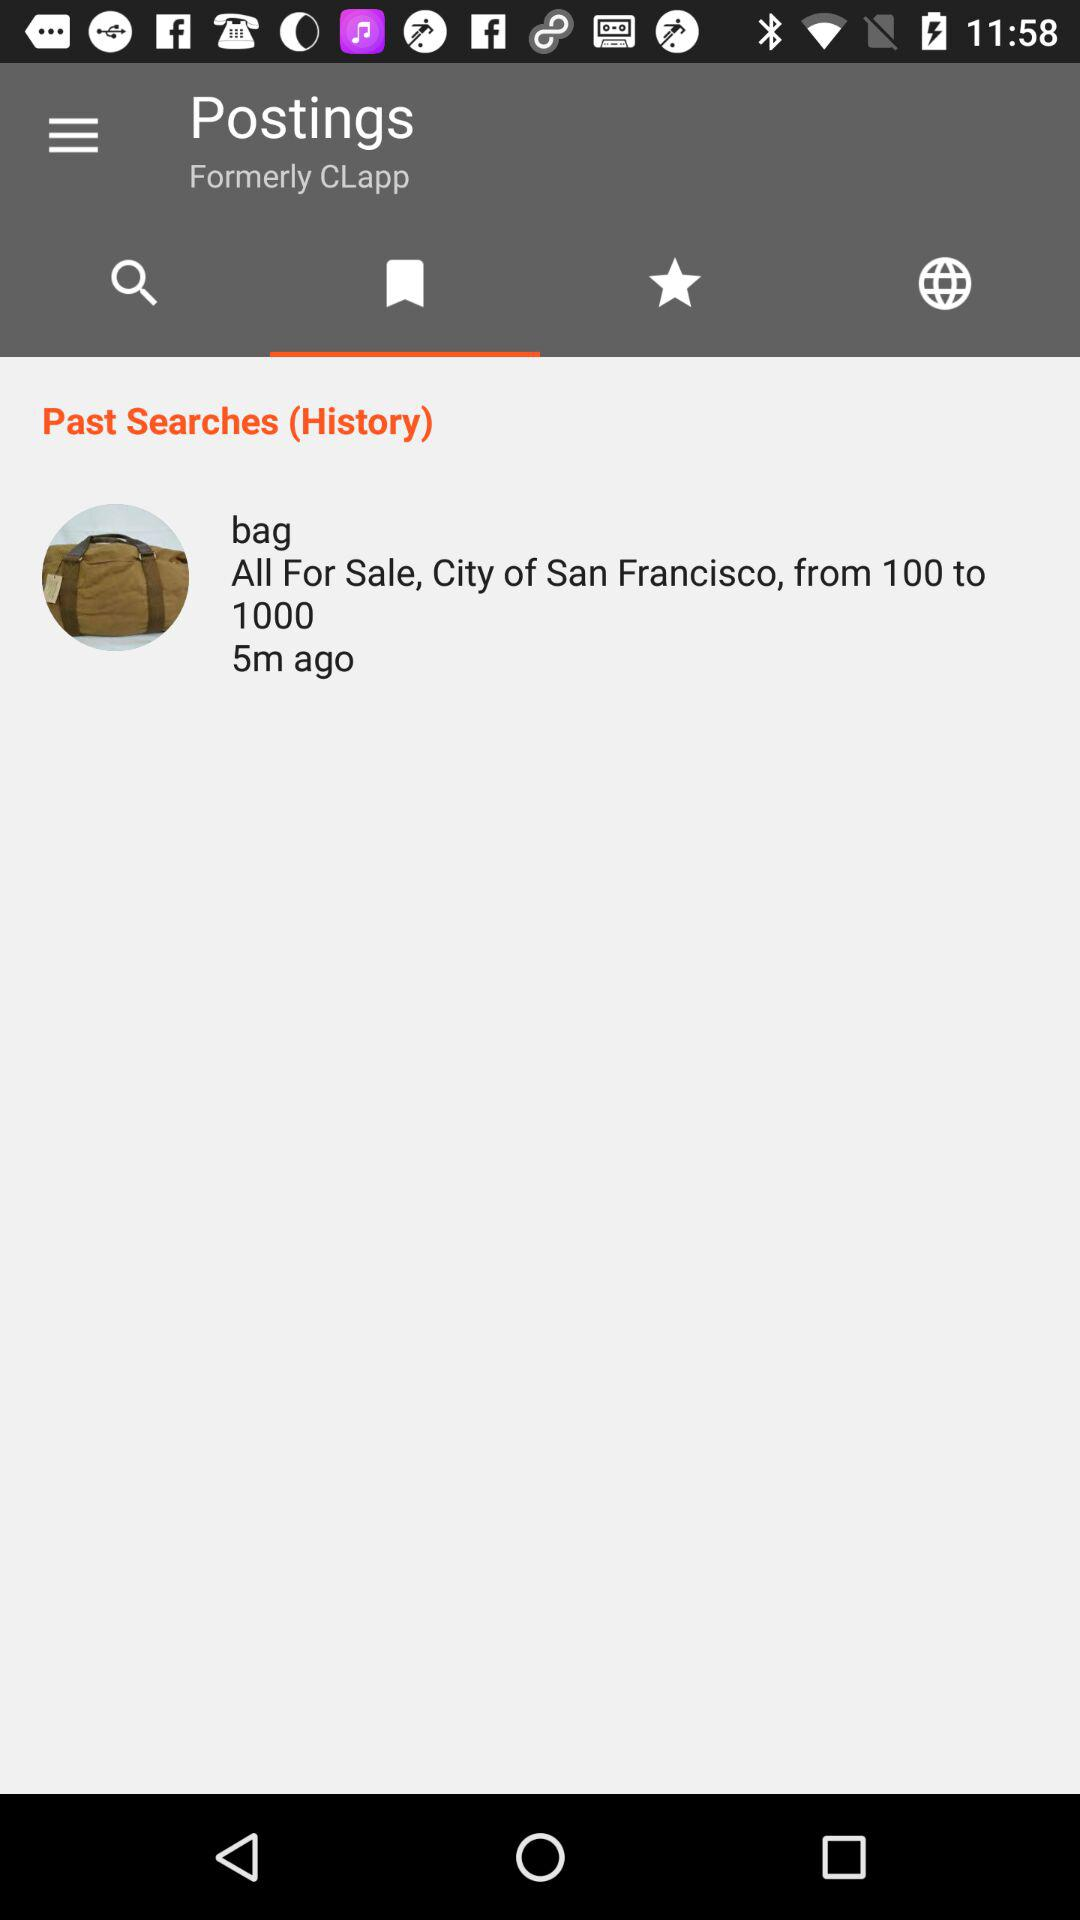What was searched 5 minutes ago? The searched item was a bag. 